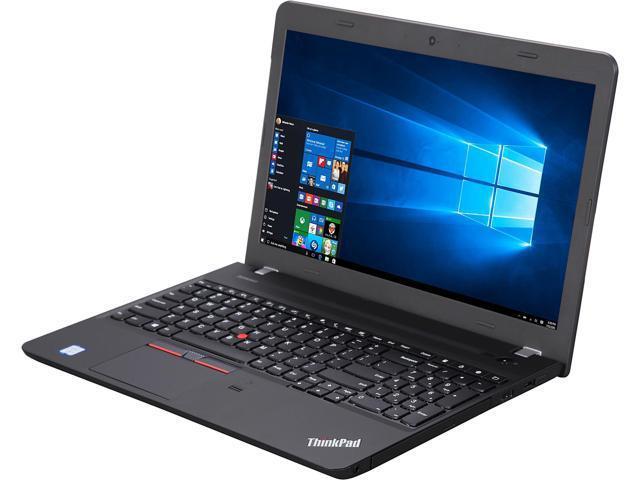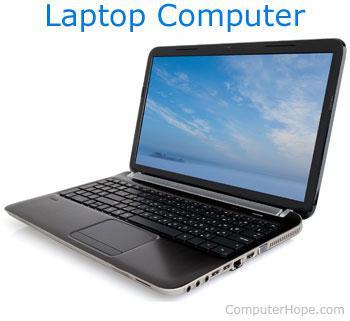The first image is the image on the left, the second image is the image on the right. Evaluate the accuracy of this statement regarding the images: "One of the images contains a laptop turned toward the right.". Is it true? Answer yes or no. No. 